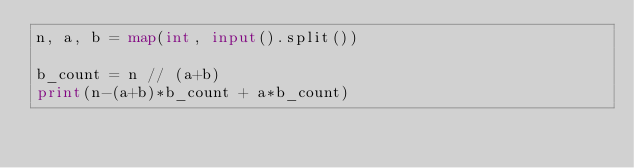<code> <loc_0><loc_0><loc_500><loc_500><_Python_>n, a, b = map(int, input().split())

b_count = n // (a+b) 
print(n-(a+b)*b_count + a*b_count)</code> 